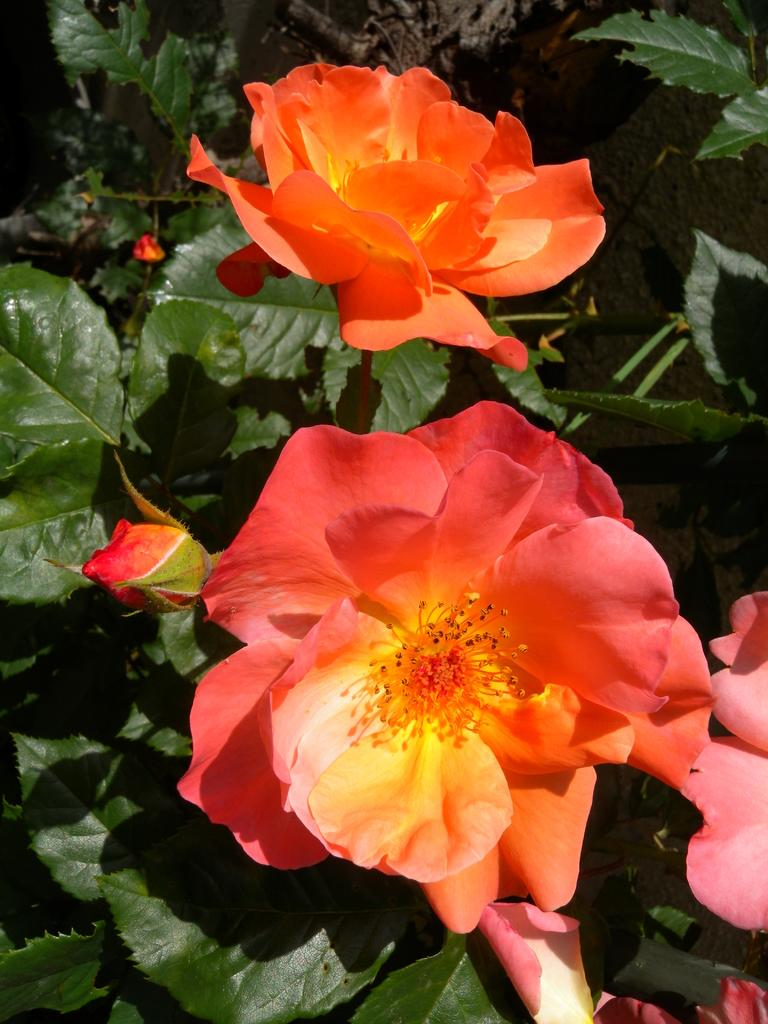What type of living organisms are present in the image? There are plants in the image. What specific features can be observed on the plants? The plants have flowers and buds. What type of chain can be seen hanging from the flowers in the image? There is no chain present in the image; it features plants with flowers and buds. How many horses are visible in the image? There are no horses present in the image; it features plants with flowers and buds. 